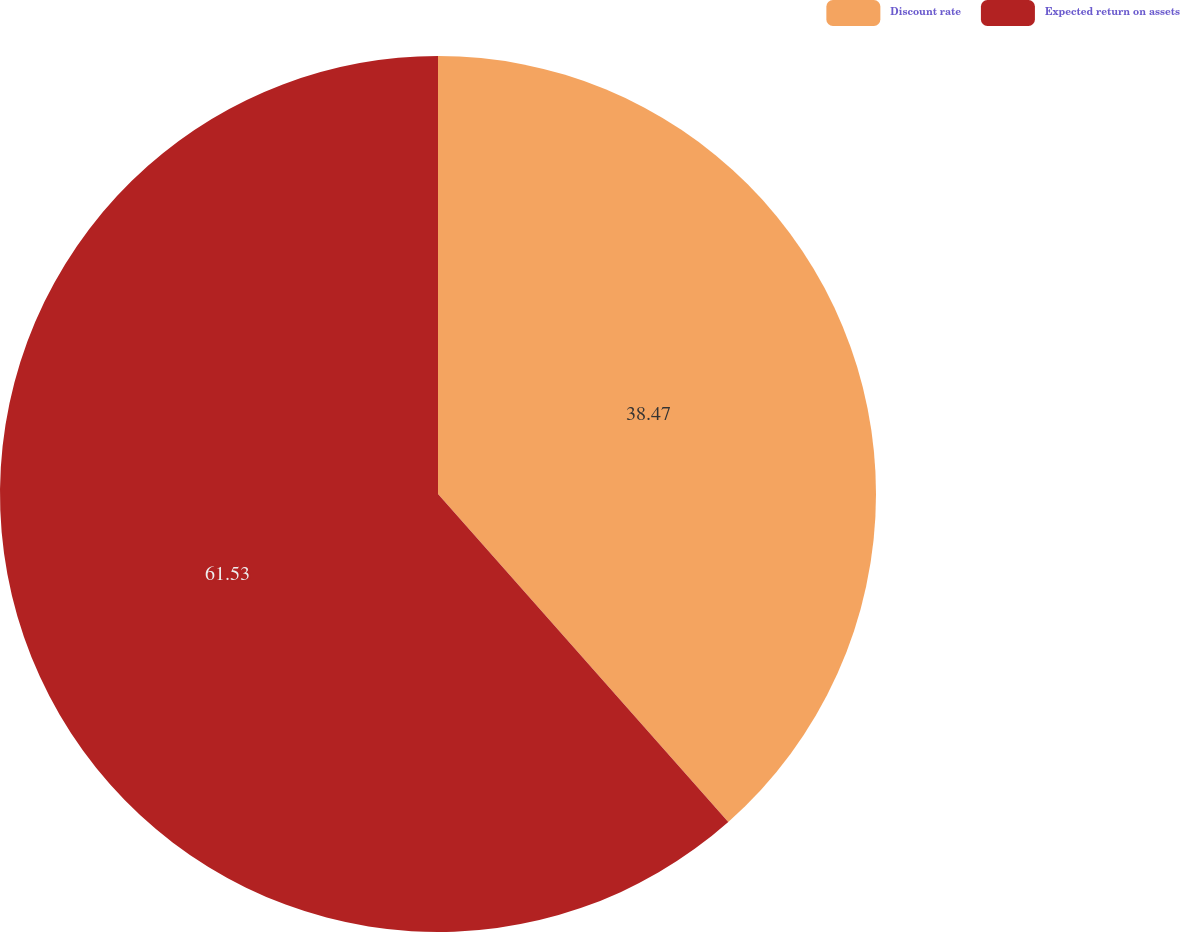<chart> <loc_0><loc_0><loc_500><loc_500><pie_chart><fcel>Discount rate<fcel>Expected return on assets<nl><fcel>38.47%<fcel>61.53%<nl></chart> 